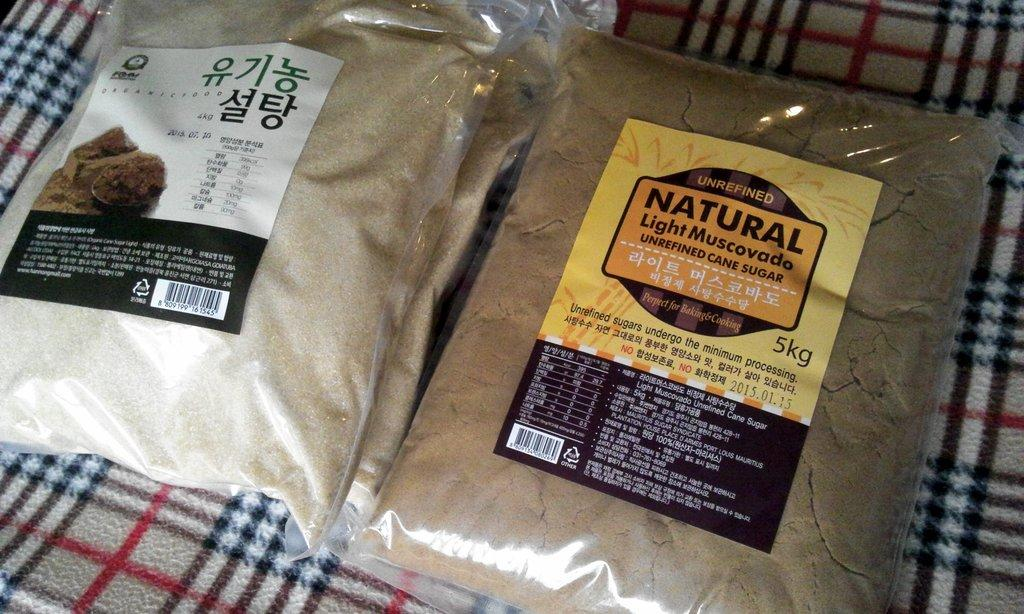What items are present in the image? There are sugar packets in the image. Where are the sugar packets located? The sugar packets are present on a blanket. What type of competition is taking place on the blanket in the image? There is no competition present in the image; it only features sugar packets on a blanket. 